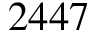Convert formula to latex. <formula><loc_0><loc_0><loc_500><loc_500>2 4 4 7</formula> 